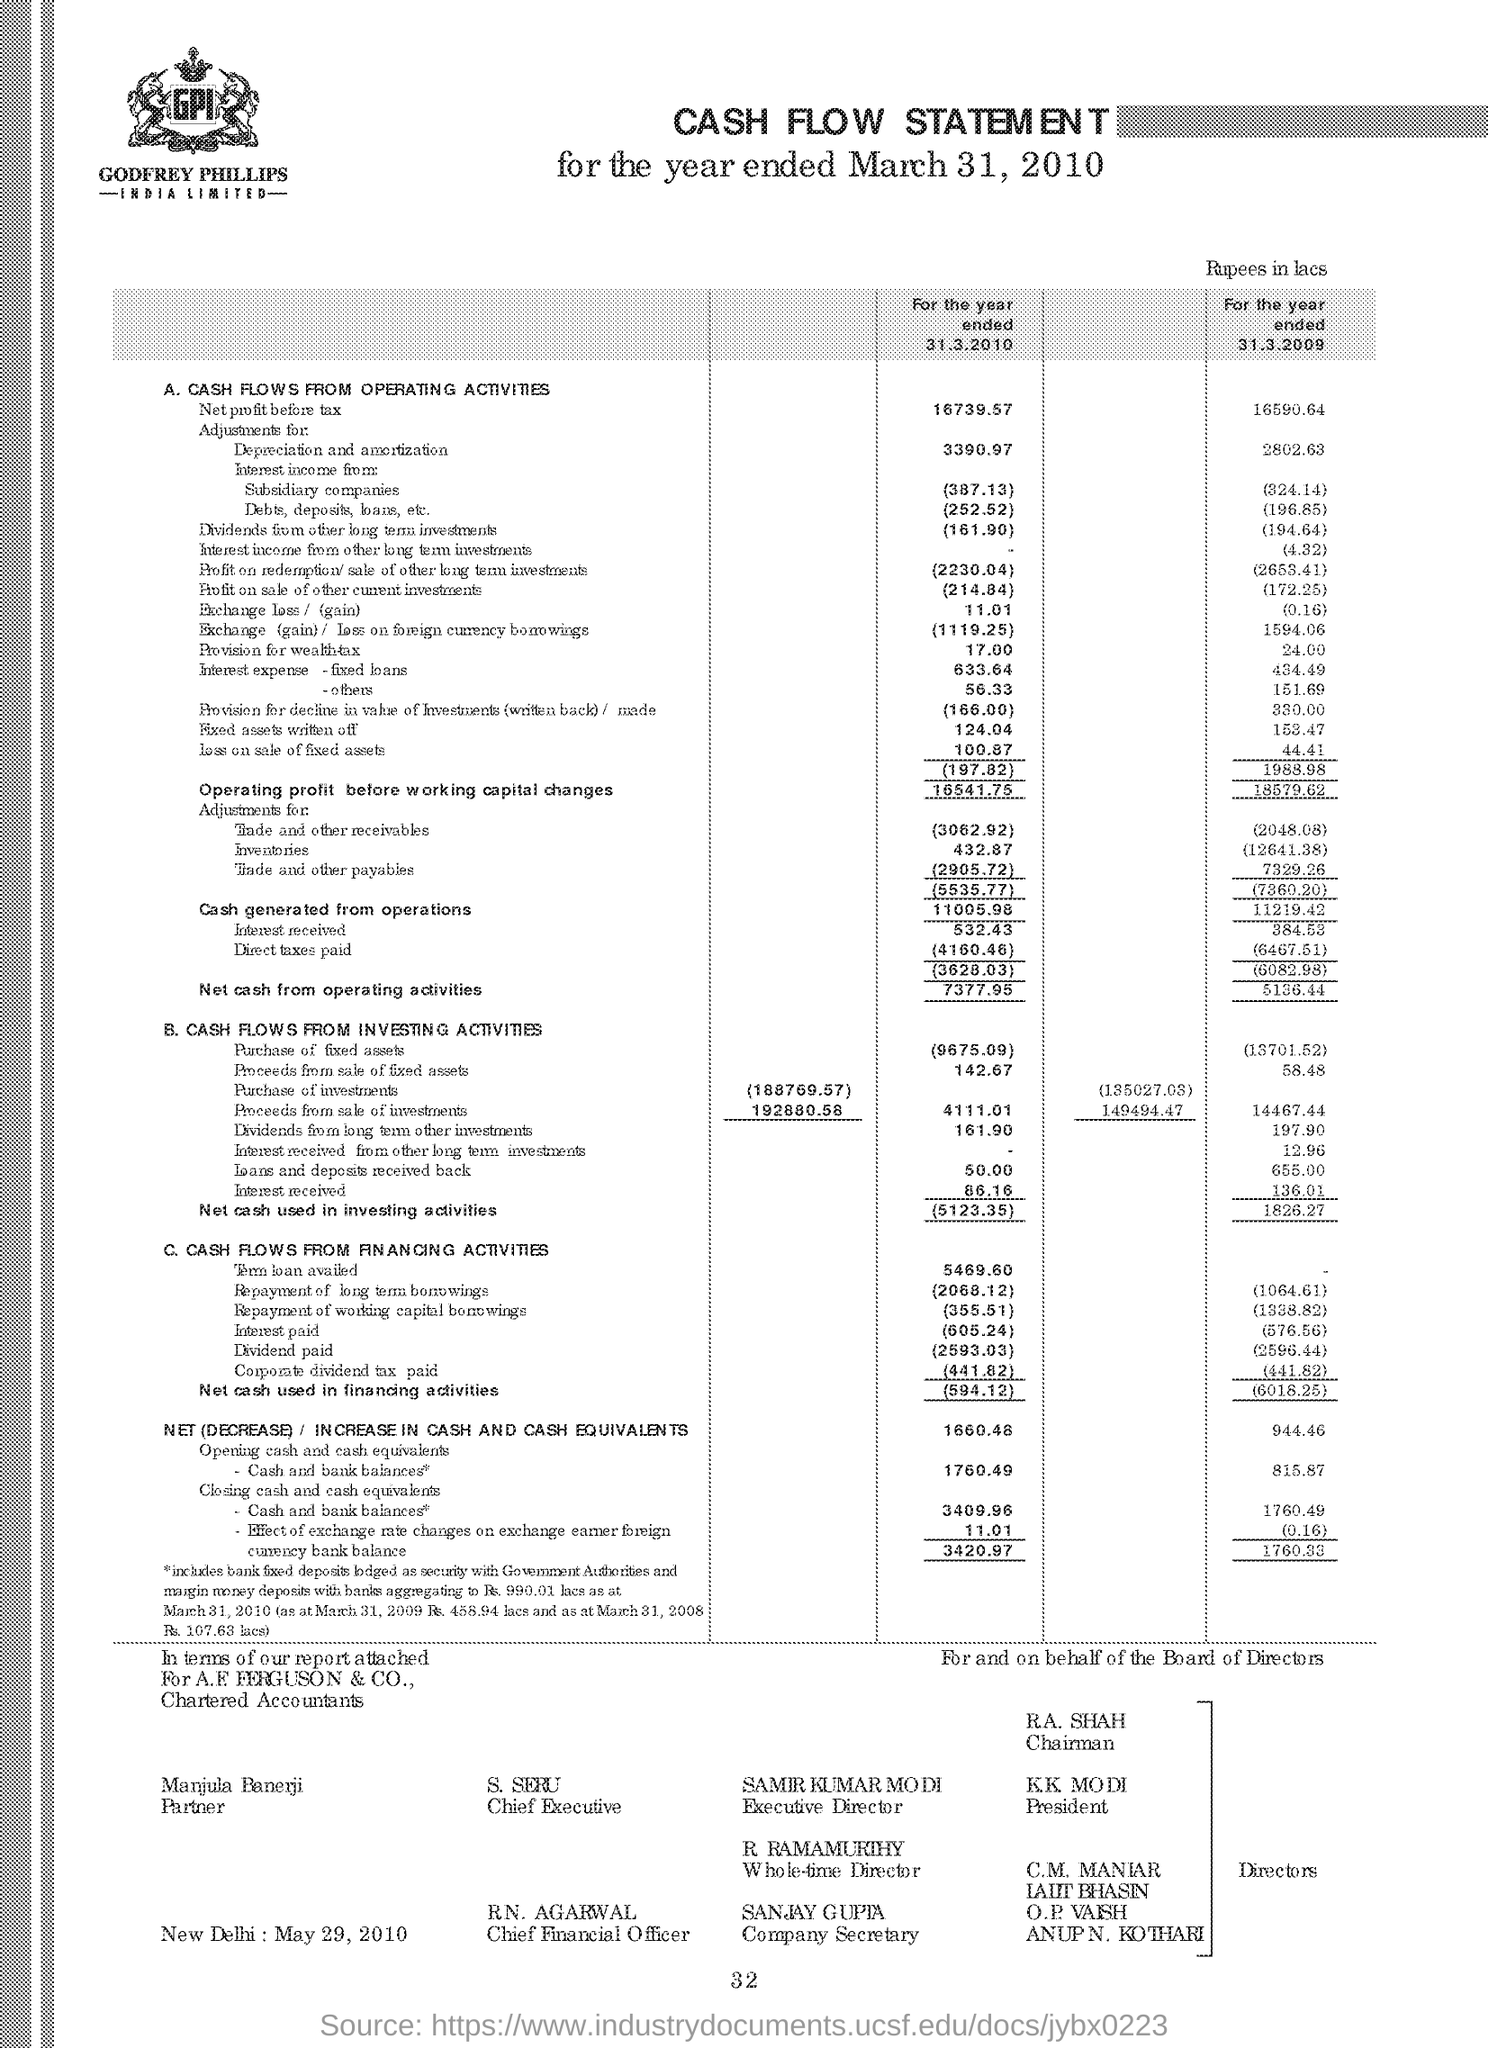Highlight a few significant elements in this photo. A.F. Ferguson & Co. are mentioned. 